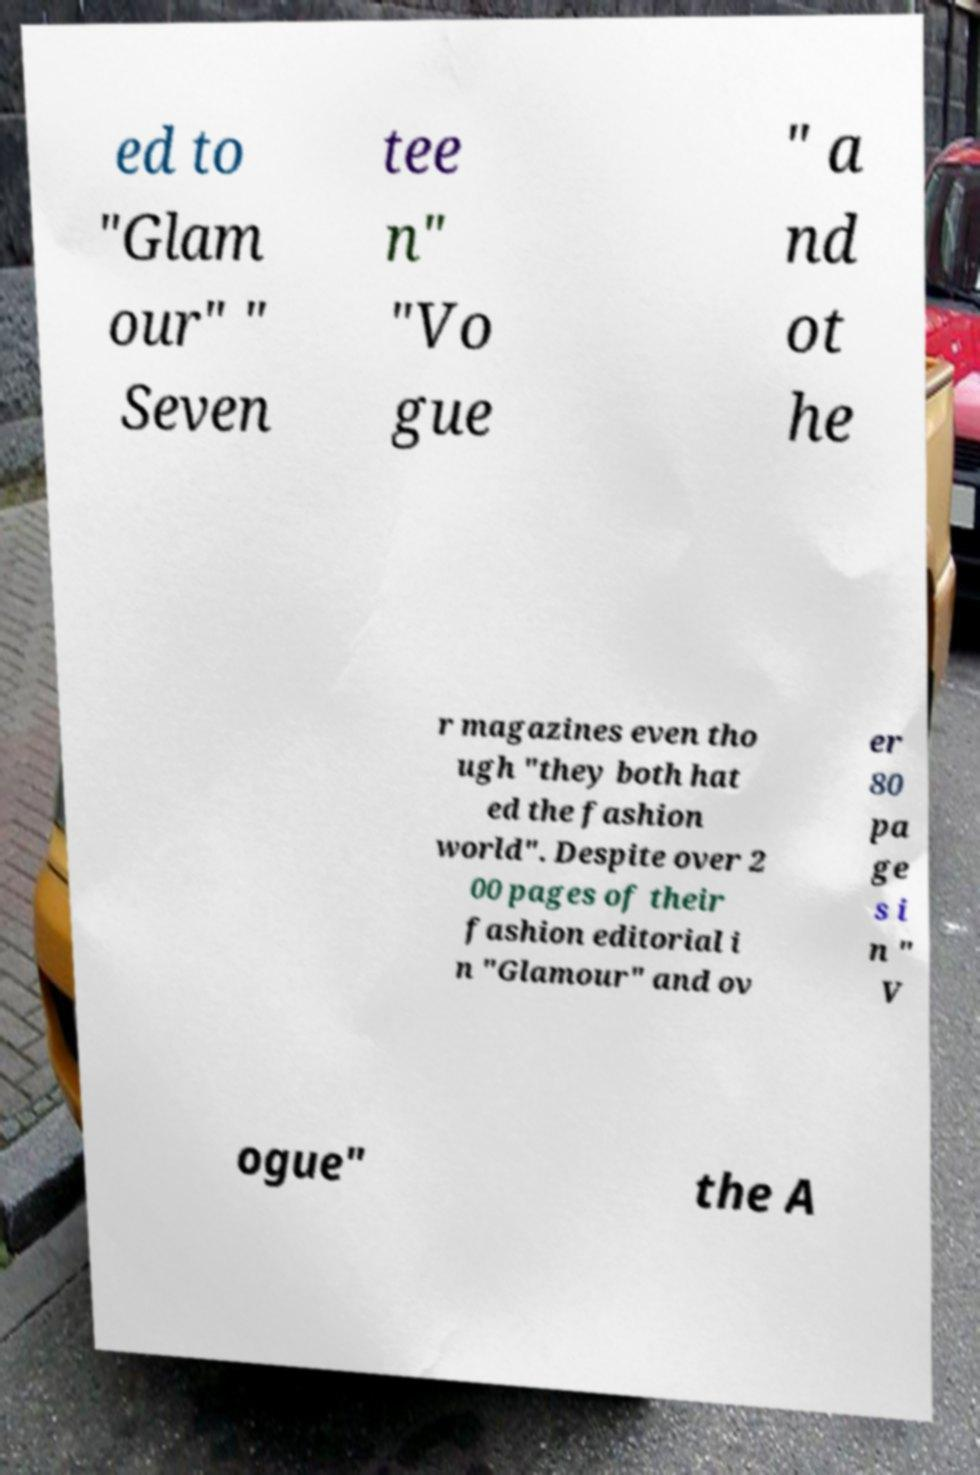Please identify and transcribe the text found in this image. ed to "Glam our" " Seven tee n" "Vo gue " a nd ot he r magazines even tho ugh "they both hat ed the fashion world". Despite over 2 00 pages of their fashion editorial i n "Glamour" and ov er 80 pa ge s i n " V ogue" the A 